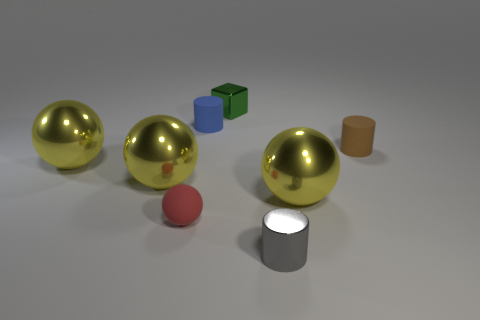What number of tiny brown things are behind the small cylinder that is to the left of the cylinder in front of the small brown thing?
Provide a short and direct response. 0. Are there any other tiny objects made of the same material as the tiny gray thing?
Make the answer very short. Yes. Is the number of large brown shiny blocks less than the number of red balls?
Your response must be concise. Yes. What material is the yellow sphere that is right of the tiny cylinder on the left side of the thing in front of the small red matte sphere?
Make the answer very short. Metal. Are there fewer small metallic objects in front of the small brown object than small shiny blocks?
Make the answer very short. No. Is the size of the matte cylinder that is to the left of the metal cylinder the same as the brown cylinder?
Offer a very short reply. Yes. What number of matte things are both to the left of the gray metal cylinder and behind the small red rubber thing?
Provide a succinct answer. 1. What size is the rubber thing to the right of the thing behind the small blue cylinder?
Your answer should be compact. Small. Are there fewer small rubber cylinders that are behind the blue rubber thing than yellow metallic spheres right of the red object?
Offer a very short reply. Yes. There is a cylinder that is left of the brown matte object and in front of the blue rubber cylinder; what material is it made of?
Ensure brevity in your answer.  Metal. 